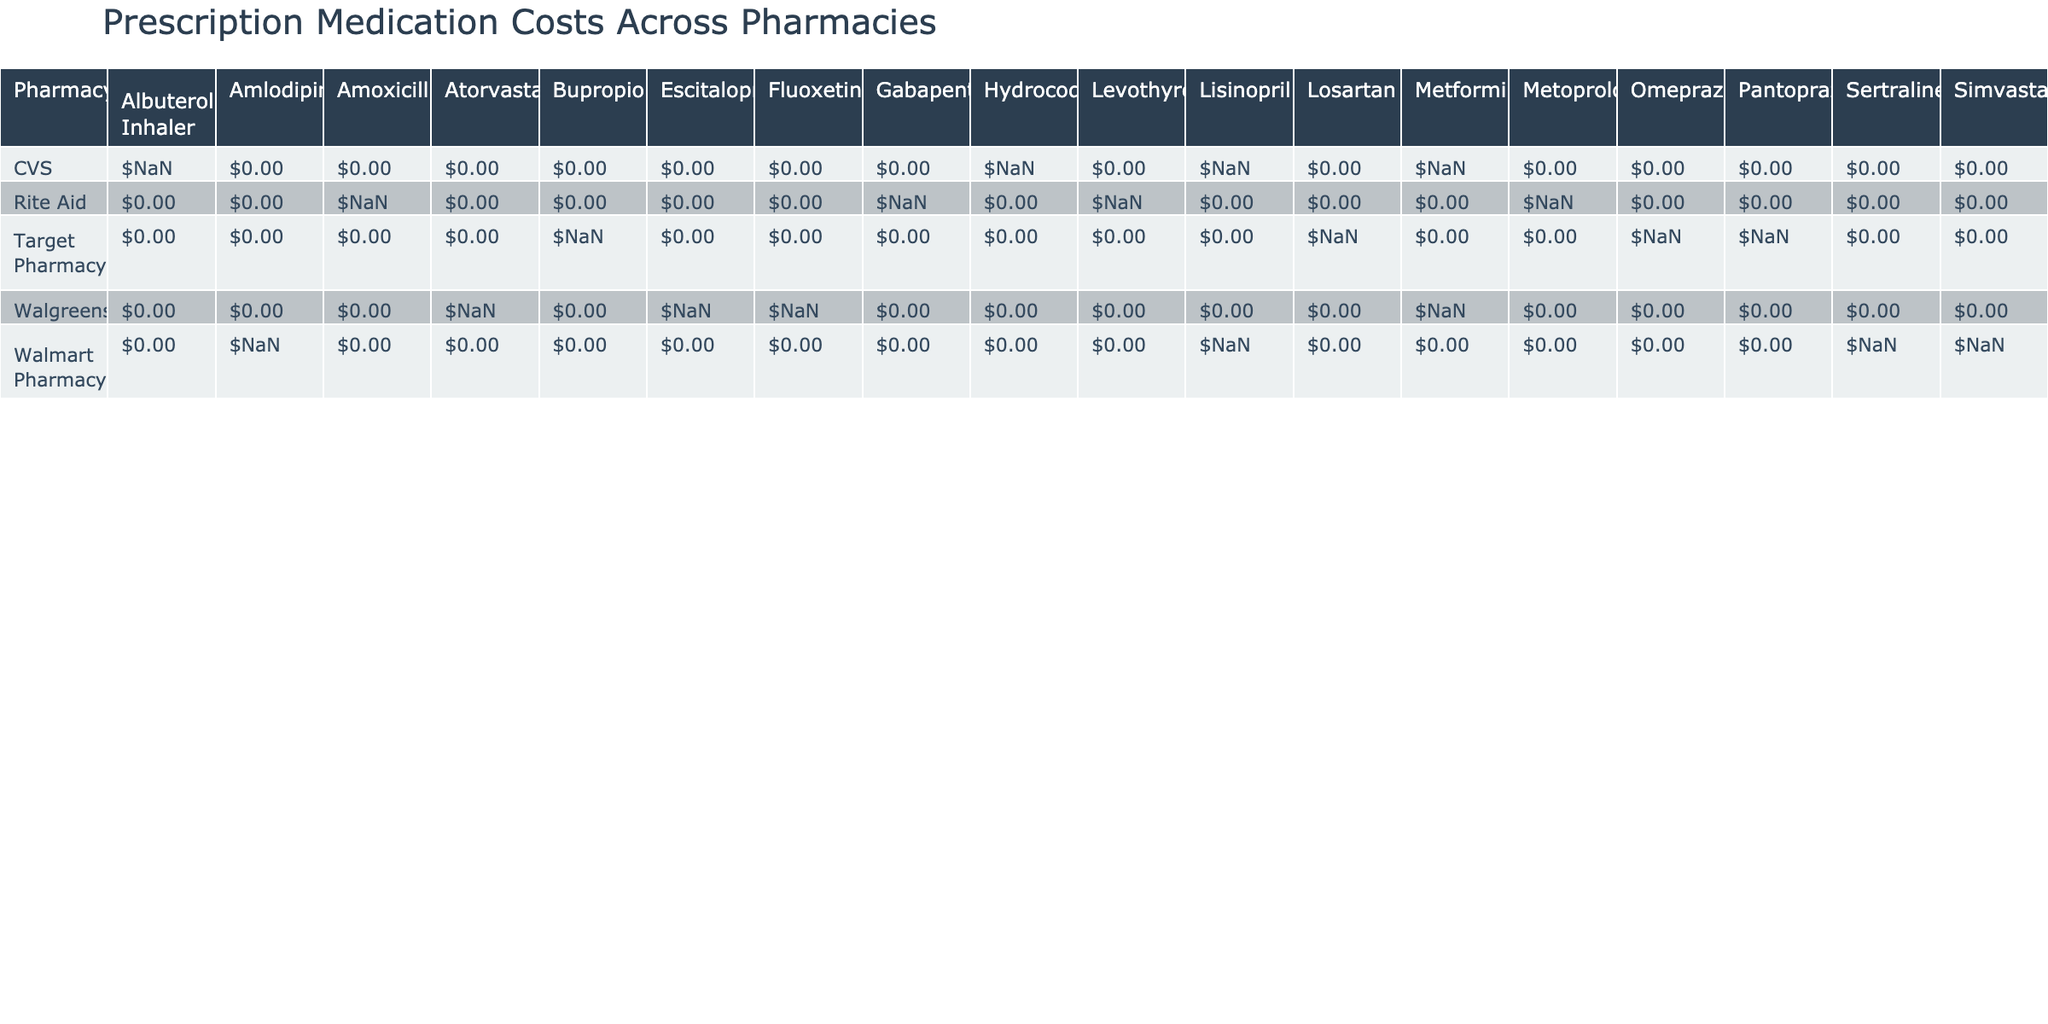What is the price of Lisinopril at CVS? According to the table, the price of Lisinopril at CVS is listed under the CVS row and the Lisinopril column, which is $15.99.
Answer: $15.99 Which pharmacy offers the cheapest price for Sertraline? By comparing the prices for Sertraline across the pharmacies, Walmart Pharmacy has a price of $7.50, which is lower than other listed prices for Sertraline.
Answer: Walmart Pharmacy: $7.50 How many medications have a price over $20? In the table, I will enumerate the entries that are priced over $20: Metformin at Walgreens ($24.50), Atorvastatin at Walgreens ($35.50), Gabapentin at Rite Aid ($42.25), Fluoxetine at Walgreens ($22.50), and Bupropion at Target Pharmacy ($29.99). This gives us a total of 5 medications.
Answer: 5 Is Rite Aid accepting insurance for Levothyroxine? The table shows that for Levothyroxine at Rite Aid, the "Insurance Accepted" column states "No", indicating that they do not accept insurance for this medication.
Answer: No What is the average cost of medications at Walmart Pharmacy? To find the average, first, I will total the prices of medications at Walmart Pharmacy: Amlodipine ($9.00), Sertraline ($7.50), and Lisinopril ($10.00). The sum is $26.50, and there are 3 medications, so the average is calculated as $26.50 / 3 = $8.83.
Answer: $8.83 Which pharmacy has the maximum price for the Albuterol Inhaler? The price of the Albuterol Inhaler at CVS is distinct and noted as $59.99, making it the maximum price listed for this medication in the table.
Answer: CVS: $59.99 How many pharmacies accept insurance for Gabapentin? The table indicates that Gabapentin is priced at Rite Aid and it states "Yes" for the insurance accepted. Since Rite Aid is the only pharmacy listed for Gabapentin, the count is 1.
Answer: 1 Which medication has the highest price overall? By reviewing the prices across the table, Albuterol Inhaler at CVS priced at $59.99 is the highest compared to others, thus confirming it as the highest price overall.
Answer: Albuterol Inhaler: $59.99 Has Target Pharmacy the lowest price for any medication? Upon checking prices, Walmart Pharmacy offers Amlodipine for $9.00, which is lower than any medication offered by Target Pharmacy. Therefore, Target Pharmacy does not have the lowest price for any medication listed.
Answer: No 